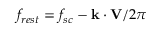Convert formula to latex. <formula><loc_0><loc_0><loc_500><loc_500>f _ { r e s t } = f _ { s c } - k \cdot V / 2 \pi</formula> 